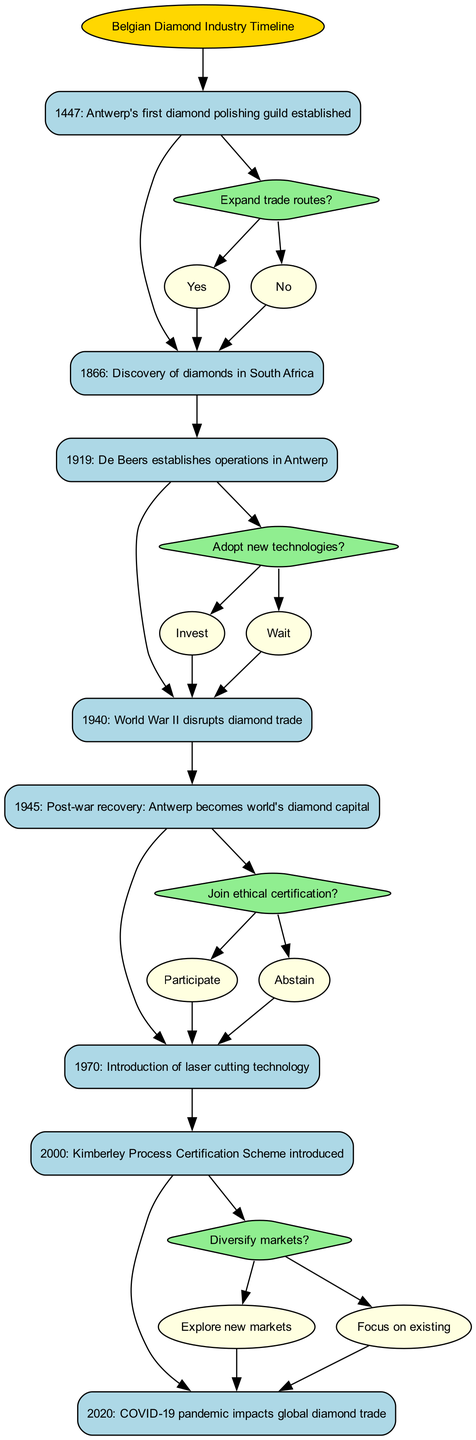What significant event was marked in 1447? The diagram shows that in 1447, Antwerp's first diamond polishing guild was established, represented as the first notable event in the timeline.
Answer: Antwerp's first diamond polishing guild established What major disruption occurred in 1940? According to the diagram, World War II disrupted the diamond trade, indicated as a significant event affecting the industry.
Answer: World War II disrupts diamond trade How many decision points are present in the diagram? By analyzing the diagram, there are four decision points labeled as D1, D2, D3, and D4, indicating critical choices within the timeline.
Answer: 4 What technology was introduced in 1970? The diagram indicates that in 1970, laser cutting technology was introduced, marking an advancement in the diamond industry.
Answer: Introduction of laser cutting technology What happens if the decision at D2 is to invest in new technologies? Following the decision tree logic, if the choice at D2 is to invest, it leads to the next event node, which is the introduction of laser cutting technology in 1970, showing a proactive response to technological advancement.
Answer: Introduction of laser cutting technology Which event follows the decision to join ethical certification? The decision to join ethical certification (D3) leads to the node representing the Kimberley Process Certification Scheme introduced in 2000, indicating a significant shift in ethical practices within the diamond industry.
Answer: Kimberley Process Certification Scheme introduced What years frame the timeline of this diagram? The earliest event is in 1447, and the latest is in 2020, showing that the timeline spans from the mid-15th century to the early 21st century.
Answer: 1447 to 2020 What was the outcome after deciding to expand trade routes in the 1919 decision? Should the decision to expand trade routes be made, the historical timeline does not provide further events linked directly, but logically suggests increased trade activity initiated by De Beers' operations in Antwerp in 1919.
Answer: Increased trade activity 